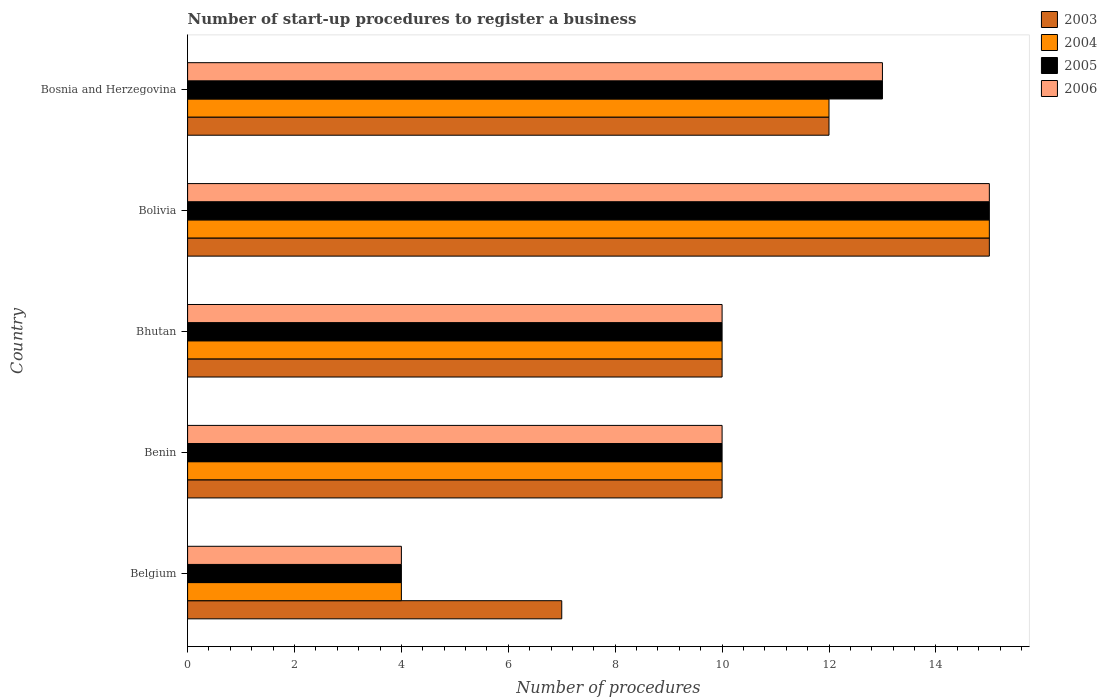How many different coloured bars are there?
Keep it short and to the point. 4. Are the number of bars on each tick of the Y-axis equal?
Give a very brief answer. Yes. How many bars are there on the 5th tick from the top?
Offer a very short reply. 4. How many bars are there on the 1st tick from the bottom?
Make the answer very short. 4. What is the label of the 2nd group of bars from the top?
Your answer should be compact. Bolivia. What is the number of procedures required to register a business in 2006 in Bhutan?
Your answer should be very brief. 10. Across all countries, what is the minimum number of procedures required to register a business in 2005?
Your answer should be compact. 4. In which country was the number of procedures required to register a business in 2003 maximum?
Provide a short and direct response. Bolivia. In which country was the number of procedures required to register a business in 2004 minimum?
Provide a short and direct response. Belgium. What is the difference between the number of procedures required to register a business in 2004 in Belgium and that in Bolivia?
Give a very brief answer. -11. What is the difference between the number of procedures required to register a business in 2004 in Bhutan and the number of procedures required to register a business in 2003 in Bosnia and Herzegovina?
Your answer should be very brief. -2. What is the average number of procedures required to register a business in 2006 per country?
Offer a very short reply. 10.4. In how many countries, is the number of procedures required to register a business in 2005 greater than 14.4 ?
Keep it short and to the point. 1. What is the ratio of the number of procedures required to register a business in 2003 in Belgium to that in Bolivia?
Your answer should be very brief. 0.47. Is the number of procedures required to register a business in 2004 in Belgium less than that in Benin?
Provide a short and direct response. Yes. In how many countries, is the number of procedures required to register a business in 2003 greater than the average number of procedures required to register a business in 2003 taken over all countries?
Offer a very short reply. 2. Is it the case that in every country, the sum of the number of procedures required to register a business in 2004 and number of procedures required to register a business in 2003 is greater than the sum of number of procedures required to register a business in 2006 and number of procedures required to register a business in 2005?
Offer a very short reply. No. How many bars are there?
Offer a very short reply. 20. What is the difference between two consecutive major ticks on the X-axis?
Offer a very short reply. 2. Does the graph contain any zero values?
Provide a short and direct response. No. How many legend labels are there?
Ensure brevity in your answer.  4. What is the title of the graph?
Keep it short and to the point. Number of start-up procedures to register a business. What is the label or title of the X-axis?
Make the answer very short. Number of procedures. What is the label or title of the Y-axis?
Your response must be concise. Country. What is the Number of procedures in 2004 in Belgium?
Offer a terse response. 4. What is the Number of procedures in 2005 in Belgium?
Offer a terse response. 4. What is the Number of procedures in 2006 in Belgium?
Your answer should be very brief. 4. What is the Number of procedures in 2005 in Benin?
Offer a very short reply. 10. What is the Number of procedures in 2006 in Benin?
Offer a very short reply. 10. What is the Number of procedures in 2003 in Bhutan?
Make the answer very short. 10. What is the Number of procedures in 2004 in Bhutan?
Provide a short and direct response. 10. What is the Number of procedures in 2006 in Bhutan?
Provide a short and direct response. 10. What is the Number of procedures in 2004 in Bolivia?
Provide a short and direct response. 15. What is the Number of procedures in 2005 in Bolivia?
Offer a very short reply. 15. Across all countries, what is the minimum Number of procedures in 2003?
Provide a succinct answer. 7. Across all countries, what is the minimum Number of procedures in 2004?
Provide a succinct answer. 4. What is the total Number of procedures in 2006 in the graph?
Provide a succinct answer. 52. What is the difference between the Number of procedures of 2003 in Belgium and that in Benin?
Ensure brevity in your answer.  -3. What is the difference between the Number of procedures in 2005 in Belgium and that in Benin?
Your response must be concise. -6. What is the difference between the Number of procedures of 2004 in Belgium and that in Bhutan?
Offer a very short reply. -6. What is the difference between the Number of procedures in 2005 in Belgium and that in Bhutan?
Provide a succinct answer. -6. What is the difference between the Number of procedures in 2005 in Belgium and that in Bolivia?
Your response must be concise. -11. What is the difference between the Number of procedures of 2006 in Belgium and that in Bolivia?
Your response must be concise. -11. What is the difference between the Number of procedures in 2006 in Belgium and that in Bosnia and Herzegovina?
Give a very brief answer. -9. What is the difference between the Number of procedures of 2003 in Benin and that in Bhutan?
Your response must be concise. 0. What is the difference between the Number of procedures in 2006 in Benin and that in Bhutan?
Provide a short and direct response. 0. What is the difference between the Number of procedures of 2003 in Benin and that in Bolivia?
Give a very brief answer. -5. What is the difference between the Number of procedures of 2004 in Benin and that in Bolivia?
Offer a terse response. -5. What is the difference between the Number of procedures in 2004 in Benin and that in Bosnia and Herzegovina?
Keep it short and to the point. -2. What is the difference between the Number of procedures in 2006 in Benin and that in Bosnia and Herzegovina?
Provide a succinct answer. -3. What is the difference between the Number of procedures in 2003 in Bhutan and that in Bolivia?
Make the answer very short. -5. What is the difference between the Number of procedures of 2004 in Bhutan and that in Bolivia?
Your response must be concise. -5. What is the difference between the Number of procedures in 2005 in Bhutan and that in Bolivia?
Your response must be concise. -5. What is the difference between the Number of procedures of 2004 in Bolivia and that in Bosnia and Herzegovina?
Provide a succinct answer. 3. What is the difference between the Number of procedures in 2003 in Belgium and the Number of procedures in 2004 in Benin?
Provide a short and direct response. -3. What is the difference between the Number of procedures of 2003 in Belgium and the Number of procedures of 2005 in Benin?
Offer a very short reply. -3. What is the difference between the Number of procedures of 2004 in Belgium and the Number of procedures of 2005 in Benin?
Offer a terse response. -6. What is the difference between the Number of procedures in 2005 in Belgium and the Number of procedures in 2006 in Benin?
Your response must be concise. -6. What is the difference between the Number of procedures in 2004 in Belgium and the Number of procedures in 2006 in Bhutan?
Your response must be concise. -6. What is the difference between the Number of procedures of 2005 in Belgium and the Number of procedures of 2006 in Bhutan?
Your response must be concise. -6. What is the difference between the Number of procedures of 2003 in Belgium and the Number of procedures of 2005 in Bolivia?
Make the answer very short. -8. What is the difference between the Number of procedures of 2003 in Belgium and the Number of procedures of 2006 in Bolivia?
Offer a terse response. -8. What is the difference between the Number of procedures of 2005 in Belgium and the Number of procedures of 2006 in Bolivia?
Ensure brevity in your answer.  -11. What is the difference between the Number of procedures in 2003 in Belgium and the Number of procedures in 2004 in Bosnia and Herzegovina?
Offer a very short reply. -5. What is the difference between the Number of procedures in 2003 in Belgium and the Number of procedures in 2005 in Bosnia and Herzegovina?
Your answer should be compact. -6. What is the difference between the Number of procedures of 2003 in Belgium and the Number of procedures of 2006 in Bosnia and Herzegovina?
Ensure brevity in your answer.  -6. What is the difference between the Number of procedures of 2004 in Belgium and the Number of procedures of 2006 in Bosnia and Herzegovina?
Give a very brief answer. -9. What is the difference between the Number of procedures of 2004 in Benin and the Number of procedures of 2005 in Bhutan?
Offer a very short reply. 0. What is the difference between the Number of procedures in 2005 in Benin and the Number of procedures in 2006 in Bhutan?
Your response must be concise. 0. What is the difference between the Number of procedures of 2003 in Benin and the Number of procedures of 2006 in Bolivia?
Make the answer very short. -5. What is the difference between the Number of procedures in 2004 in Benin and the Number of procedures in 2006 in Bolivia?
Offer a very short reply. -5. What is the difference between the Number of procedures of 2003 in Benin and the Number of procedures of 2005 in Bosnia and Herzegovina?
Your response must be concise. -3. What is the difference between the Number of procedures in 2003 in Benin and the Number of procedures in 2006 in Bosnia and Herzegovina?
Ensure brevity in your answer.  -3. What is the difference between the Number of procedures of 2004 in Benin and the Number of procedures of 2005 in Bosnia and Herzegovina?
Offer a terse response. -3. What is the difference between the Number of procedures of 2003 in Bhutan and the Number of procedures of 2004 in Bolivia?
Your answer should be compact. -5. What is the difference between the Number of procedures of 2003 in Bhutan and the Number of procedures of 2005 in Bolivia?
Your answer should be very brief. -5. What is the difference between the Number of procedures in 2004 in Bhutan and the Number of procedures in 2005 in Bolivia?
Offer a very short reply. -5. What is the difference between the Number of procedures of 2004 in Bhutan and the Number of procedures of 2005 in Bosnia and Herzegovina?
Your answer should be compact. -3. What is the difference between the Number of procedures of 2005 in Bhutan and the Number of procedures of 2006 in Bosnia and Herzegovina?
Make the answer very short. -3. What is the difference between the Number of procedures in 2003 in Bolivia and the Number of procedures in 2004 in Bosnia and Herzegovina?
Your answer should be compact. 3. What is the difference between the Number of procedures of 2003 in Bolivia and the Number of procedures of 2005 in Bosnia and Herzegovina?
Your answer should be very brief. 2. What is the difference between the Number of procedures of 2003 in Bolivia and the Number of procedures of 2006 in Bosnia and Herzegovina?
Offer a very short reply. 2. What is the difference between the Number of procedures of 2004 in Bolivia and the Number of procedures of 2006 in Bosnia and Herzegovina?
Keep it short and to the point. 2. What is the average Number of procedures in 2004 per country?
Your answer should be compact. 10.2. What is the average Number of procedures in 2006 per country?
Your answer should be very brief. 10.4. What is the difference between the Number of procedures of 2003 and Number of procedures of 2004 in Belgium?
Provide a succinct answer. 3. What is the difference between the Number of procedures in 2003 and Number of procedures in 2005 in Belgium?
Ensure brevity in your answer.  3. What is the difference between the Number of procedures of 2004 and Number of procedures of 2005 in Belgium?
Provide a succinct answer. 0. What is the difference between the Number of procedures in 2004 and Number of procedures in 2006 in Belgium?
Keep it short and to the point. 0. What is the difference between the Number of procedures in 2003 and Number of procedures in 2005 in Benin?
Ensure brevity in your answer.  0. What is the difference between the Number of procedures of 2003 and Number of procedures of 2004 in Bhutan?
Ensure brevity in your answer.  0. What is the difference between the Number of procedures in 2003 and Number of procedures in 2006 in Bhutan?
Your response must be concise. 0. What is the difference between the Number of procedures in 2004 and Number of procedures in 2005 in Bhutan?
Offer a terse response. 0. What is the difference between the Number of procedures of 2004 and Number of procedures of 2006 in Bhutan?
Provide a short and direct response. 0. What is the difference between the Number of procedures of 2005 and Number of procedures of 2006 in Bhutan?
Your answer should be compact. 0. What is the difference between the Number of procedures of 2004 and Number of procedures of 2005 in Bolivia?
Provide a succinct answer. 0. What is the difference between the Number of procedures of 2004 and Number of procedures of 2006 in Bolivia?
Give a very brief answer. 0. What is the difference between the Number of procedures of 2003 and Number of procedures of 2004 in Bosnia and Herzegovina?
Keep it short and to the point. 0. What is the difference between the Number of procedures in 2003 and Number of procedures in 2005 in Bosnia and Herzegovina?
Give a very brief answer. -1. What is the ratio of the Number of procedures of 2005 in Belgium to that in Benin?
Provide a short and direct response. 0.4. What is the ratio of the Number of procedures in 2003 in Belgium to that in Bhutan?
Offer a terse response. 0.7. What is the ratio of the Number of procedures of 2005 in Belgium to that in Bhutan?
Your answer should be very brief. 0.4. What is the ratio of the Number of procedures of 2003 in Belgium to that in Bolivia?
Ensure brevity in your answer.  0.47. What is the ratio of the Number of procedures of 2004 in Belgium to that in Bolivia?
Your response must be concise. 0.27. What is the ratio of the Number of procedures of 2005 in Belgium to that in Bolivia?
Your response must be concise. 0.27. What is the ratio of the Number of procedures in 2006 in Belgium to that in Bolivia?
Your answer should be compact. 0.27. What is the ratio of the Number of procedures in 2003 in Belgium to that in Bosnia and Herzegovina?
Keep it short and to the point. 0.58. What is the ratio of the Number of procedures in 2004 in Belgium to that in Bosnia and Herzegovina?
Your answer should be very brief. 0.33. What is the ratio of the Number of procedures of 2005 in Belgium to that in Bosnia and Herzegovina?
Your answer should be very brief. 0.31. What is the ratio of the Number of procedures of 2006 in Belgium to that in Bosnia and Herzegovina?
Keep it short and to the point. 0.31. What is the ratio of the Number of procedures in 2003 in Benin to that in Bhutan?
Your response must be concise. 1. What is the ratio of the Number of procedures in 2004 in Benin to that in Bhutan?
Offer a very short reply. 1. What is the ratio of the Number of procedures of 2005 in Benin to that in Bhutan?
Your response must be concise. 1. What is the ratio of the Number of procedures of 2003 in Benin to that in Bolivia?
Make the answer very short. 0.67. What is the ratio of the Number of procedures of 2005 in Benin to that in Bolivia?
Offer a terse response. 0.67. What is the ratio of the Number of procedures of 2006 in Benin to that in Bolivia?
Offer a terse response. 0.67. What is the ratio of the Number of procedures in 2003 in Benin to that in Bosnia and Herzegovina?
Provide a succinct answer. 0.83. What is the ratio of the Number of procedures in 2004 in Benin to that in Bosnia and Herzegovina?
Your response must be concise. 0.83. What is the ratio of the Number of procedures in 2005 in Benin to that in Bosnia and Herzegovina?
Offer a very short reply. 0.77. What is the ratio of the Number of procedures in 2006 in Benin to that in Bosnia and Herzegovina?
Provide a succinct answer. 0.77. What is the ratio of the Number of procedures of 2004 in Bhutan to that in Bolivia?
Give a very brief answer. 0.67. What is the ratio of the Number of procedures in 2006 in Bhutan to that in Bolivia?
Your answer should be very brief. 0.67. What is the ratio of the Number of procedures of 2003 in Bhutan to that in Bosnia and Herzegovina?
Your response must be concise. 0.83. What is the ratio of the Number of procedures of 2005 in Bhutan to that in Bosnia and Herzegovina?
Make the answer very short. 0.77. What is the ratio of the Number of procedures of 2006 in Bhutan to that in Bosnia and Herzegovina?
Ensure brevity in your answer.  0.77. What is the ratio of the Number of procedures in 2003 in Bolivia to that in Bosnia and Herzegovina?
Keep it short and to the point. 1.25. What is the ratio of the Number of procedures of 2005 in Bolivia to that in Bosnia and Herzegovina?
Offer a very short reply. 1.15. What is the ratio of the Number of procedures of 2006 in Bolivia to that in Bosnia and Herzegovina?
Provide a succinct answer. 1.15. What is the difference between the highest and the second highest Number of procedures in 2004?
Ensure brevity in your answer.  3. What is the difference between the highest and the second highest Number of procedures in 2006?
Provide a short and direct response. 2. What is the difference between the highest and the lowest Number of procedures in 2003?
Your answer should be very brief. 8. What is the difference between the highest and the lowest Number of procedures in 2005?
Give a very brief answer. 11. 